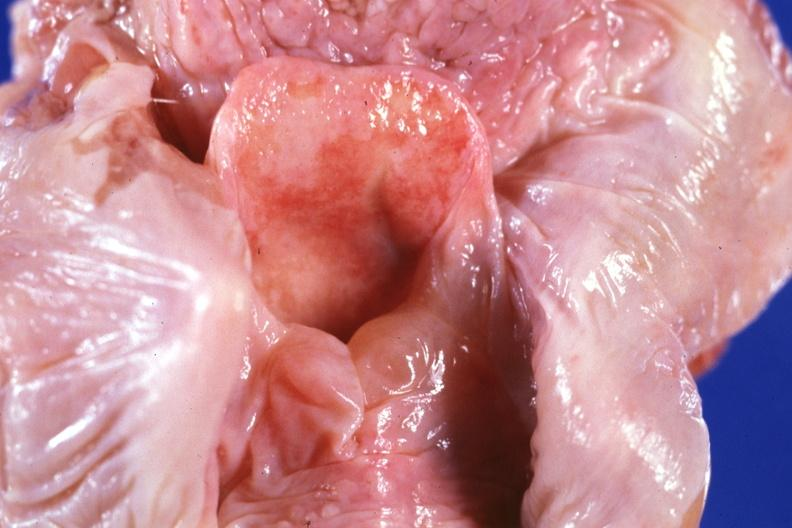what is in hypopharynx?
Answer the question using a single word or phrase. Unopened larynx seen from above edema 